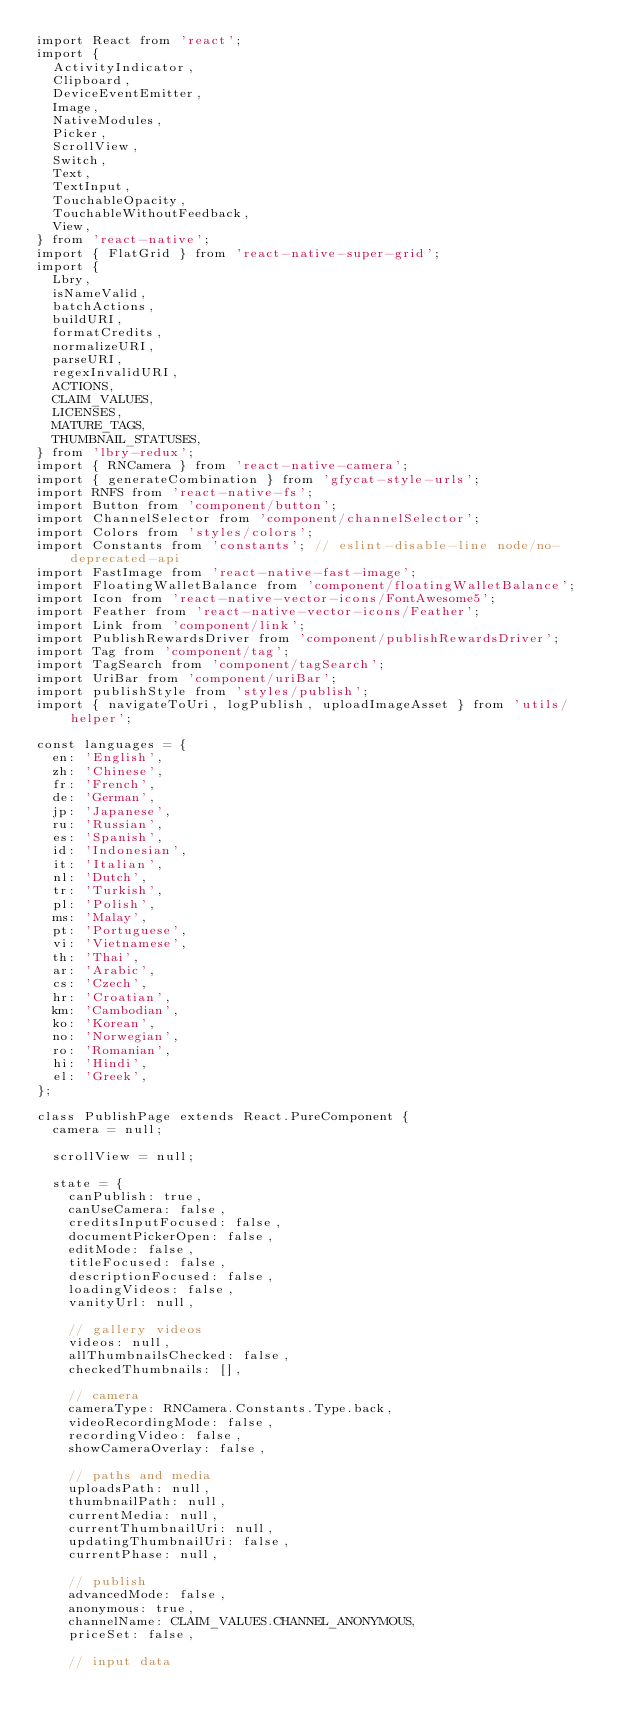<code> <loc_0><loc_0><loc_500><loc_500><_JavaScript_>import React from 'react';
import {
  ActivityIndicator,
  Clipboard,
  DeviceEventEmitter,
  Image,
  NativeModules,
  Picker,
  ScrollView,
  Switch,
  Text,
  TextInput,
  TouchableOpacity,
  TouchableWithoutFeedback,
  View,
} from 'react-native';
import { FlatGrid } from 'react-native-super-grid';
import {
  Lbry,
  isNameValid,
  batchActions,
  buildURI,
  formatCredits,
  normalizeURI,
  parseURI,
  regexInvalidURI,
  ACTIONS,
  CLAIM_VALUES,
  LICENSES,
  MATURE_TAGS,
  THUMBNAIL_STATUSES,
} from 'lbry-redux';
import { RNCamera } from 'react-native-camera';
import { generateCombination } from 'gfycat-style-urls';
import RNFS from 'react-native-fs';
import Button from 'component/button';
import ChannelSelector from 'component/channelSelector';
import Colors from 'styles/colors';
import Constants from 'constants'; // eslint-disable-line node/no-deprecated-api
import FastImage from 'react-native-fast-image';
import FloatingWalletBalance from 'component/floatingWalletBalance';
import Icon from 'react-native-vector-icons/FontAwesome5';
import Feather from 'react-native-vector-icons/Feather';
import Link from 'component/link';
import PublishRewardsDriver from 'component/publishRewardsDriver';
import Tag from 'component/tag';
import TagSearch from 'component/tagSearch';
import UriBar from 'component/uriBar';
import publishStyle from 'styles/publish';
import { navigateToUri, logPublish, uploadImageAsset } from 'utils/helper';

const languages = {
  en: 'English',
  zh: 'Chinese',
  fr: 'French',
  de: 'German',
  jp: 'Japanese',
  ru: 'Russian',
  es: 'Spanish',
  id: 'Indonesian',
  it: 'Italian',
  nl: 'Dutch',
  tr: 'Turkish',
  pl: 'Polish',
  ms: 'Malay',
  pt: 'Portuguese',
  vi: 'Vietnamese',
  th: 'Thai',
  ar: 'Arabic',
  cs: 'Czech',
  hr: 'Croatian',
  km: 'Cambodian',
  ko: 'Korean',
  no: 'Norwegian',
  ro: 'Romanian',
  hi: 'Hindi',
  el: 'Greek',
};

class PublishPage extends React.PureComponent {
  camera = null;

  scrollView = null;

  state = {
    canPublish: true,
    canUseCamera: false,
    creditsInputFocused: false,
    documentPickerOpen: false,
    editMode: false,
    titleFocused: false,
    descriptionFocused: false,
    loadingVideos: false,
    vanityUrl: null,

    // gallery videos
    videos: null,
    allThumbnailsChecked: false,
    checkedThumbnails: [],

    // camera
    cameraType: RNCamera.Constants.Type.back,
    videoRecordingMode: false,
    recordingVideo: false,
    showCameraOverlay: false,

    // paths and media
    uploadsPath: null,
    thumbnailPath: null,
    currentMedia: null,
    currentThumbnailUri: null,
    updatingThumbnailUri: false,
    currentPhase: null,

    // publish
    advancedMode: false,
    anonymous: true,
    channelName: CLAIM_VALUES.CHANNEL_ANONYMOUS,
    priceSet: false,

    // input data</code> 